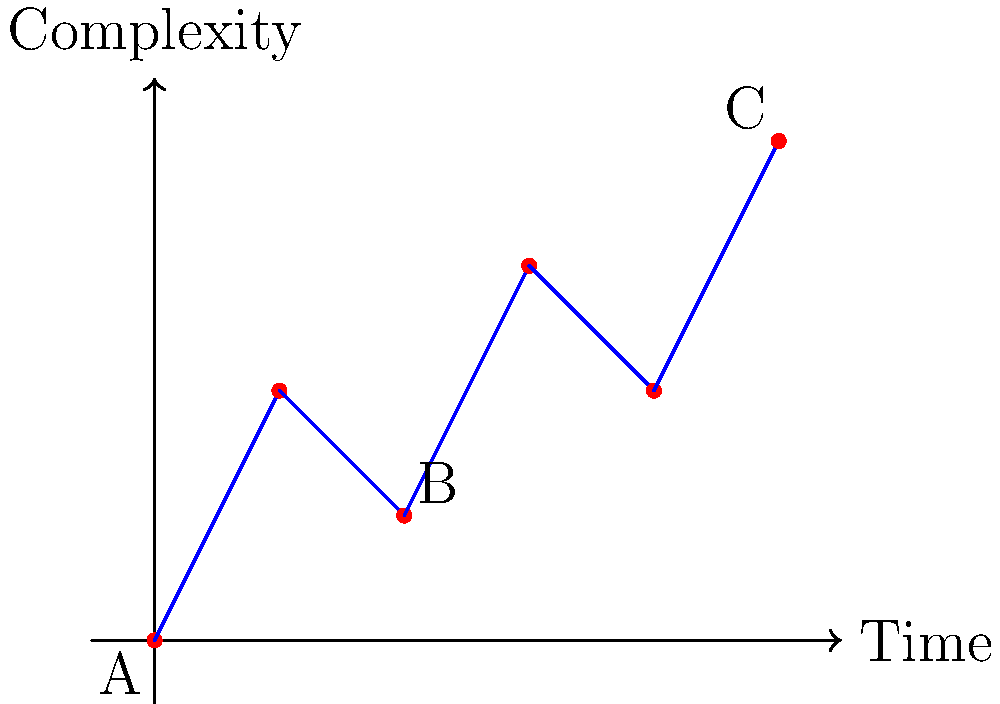In the context of using topological data analysis to visualize narrative structures in films, consider the graph above representing the complexity of a narrative over time. If we were to use persistent homology to analyze this structure, which two points would likely form the most persistent 0-dimensional feature (connected component) in the filtration process? To answer this question, we need to understand the principles of persistent homology and how it applies to narrative structures:

1. Persistent homology tracks topological features (like connected components) as we gradually connect points in the data set.

2. In this graph, the y-axis represents complexity, which we can interpret as a filtration value.

3. The filtration process would start from the bottom, gradually including points as we move up the y-axis.

4. Points that are far apart in complexity (y-axis) but close in time (x-axis) are likely to form persistent features.

5. Looking at the graph, we see that points A and B have the largest vertical distance while being relatively close horizontally.

6. This means that A and B would exist as separate connected components for a longer filtration interval compared to other point pairs.

7. While C is the highest point, it appears later in time and would likely connect to earlier points before creating a long-lasting separate component.

Therefore, points A and B would likely form the most persistent 0-dimensional feature in the filtration process, representing a significant shift in narrative complexity early in the film's timeline.
Answer: A and B 